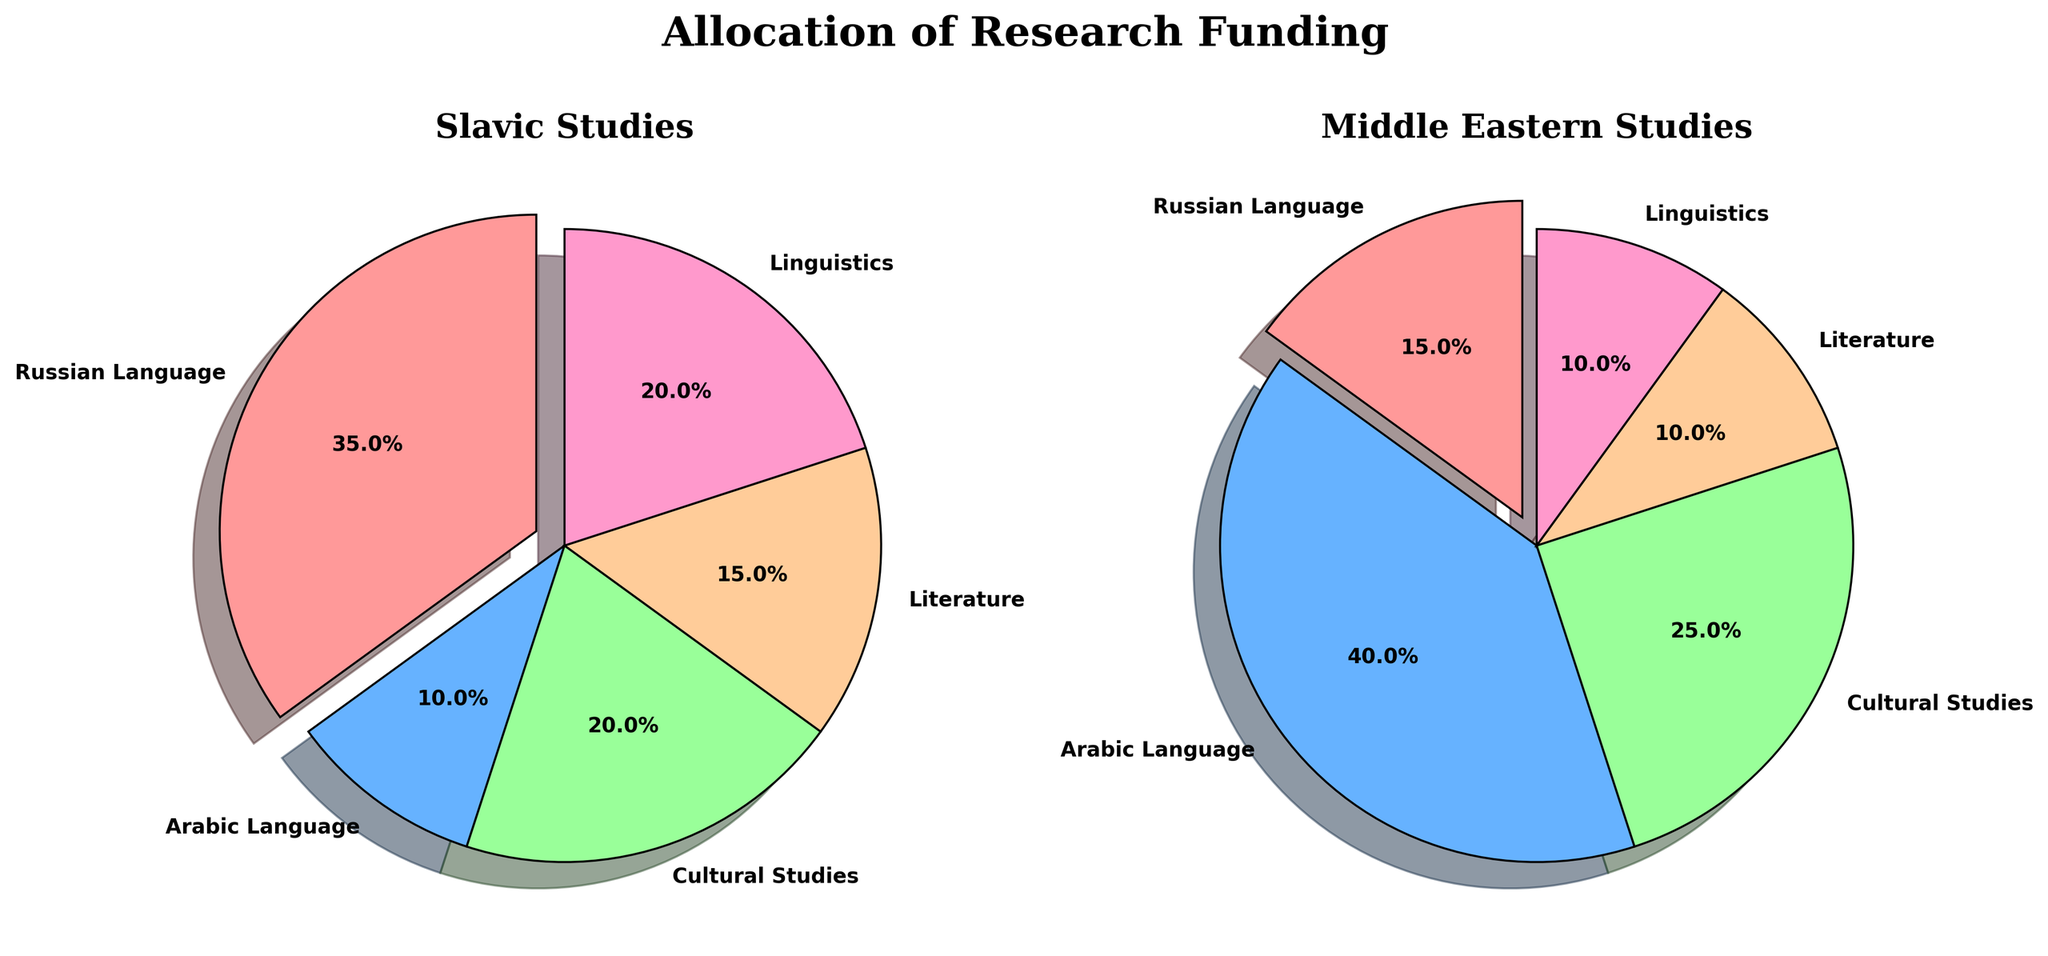what is the title of the chart? The title is located at the top center of the figure in a bold, serif font. The title text reads "Allocation of Research Funding".
Answer: Allocation of Research Funding Which category receives the most funding in Slavic Studies? Refer to the pie chart for Slavic Studies on the left. The biggest slice is marked "Russian Language" and represents 35%, which is the highest proportion.
Answer: Russian Language Which category receives the least funding in Middle Eastern Studies? Look at the Middle Eastern Studies pie chart on the right side. The smallest slice is labeled "Literature," representing 10%.
Answer: Literature What percentage of the funding is allocated to Cultural Studies in Middle Eastern Studies? Find the corresponding slice in the Middle Eastern Studies pie chart, which indicates "Cultural Studies" with a label showing 25%.
Answer: 25% Which category has the same percentage allocation in both Slavic Studies and Middle Eastern Studies? Look at both pie charts and compare the categories. Both charts show "Linguistics" with a slice representing 20% in Slavic Studies and 10% in Middle Eastern Studies.
Answer: None How much more funding (in percentage points) is allocated to the Russian Language in Slavic Studies than the Arabic Language in Middle Eastern Studies? Find the percentage for Russian Language in Slavic Studies (35%) and Arabic Language in Middle Eastern Studies (40%). Then calculate the difference: 40% - 15% = 25%.
Answer: 25% What is the combined allocation for Cultural Studies and Literature in Slavic Studies? Add the percentages for both categories in Slavic Studies: Cultural Studies (20%) + Literature (15%) = 35%.
Answer: 35% Which study area receives more funding for Cultural Studies, Slavic Studies or Middle Eastern Studies? Compare the values for Cultural Studies: 20% in Slavic Studies and 25% in Middle Eastern Studies. 25% is greater than 20%.
Answer: Middle Eastern Studies What is the total allocation percentage for language-specific studies (Russian and Arabic) in both areas? Add the percentages for Russian Language and Arabic Language in both charts: Slavic Studies (35% Russian) + Middle Eastern Studies (40% Arabic) = 75%.
Answer: 75% Which study area allocates more funding to Linguistics? Compare the values of the Linguistics category in both charts: 20% for Slavic Studies and 10% for Middle Eastern Studies. 20% is greater than 10%.
Answer: Slavic Studies 